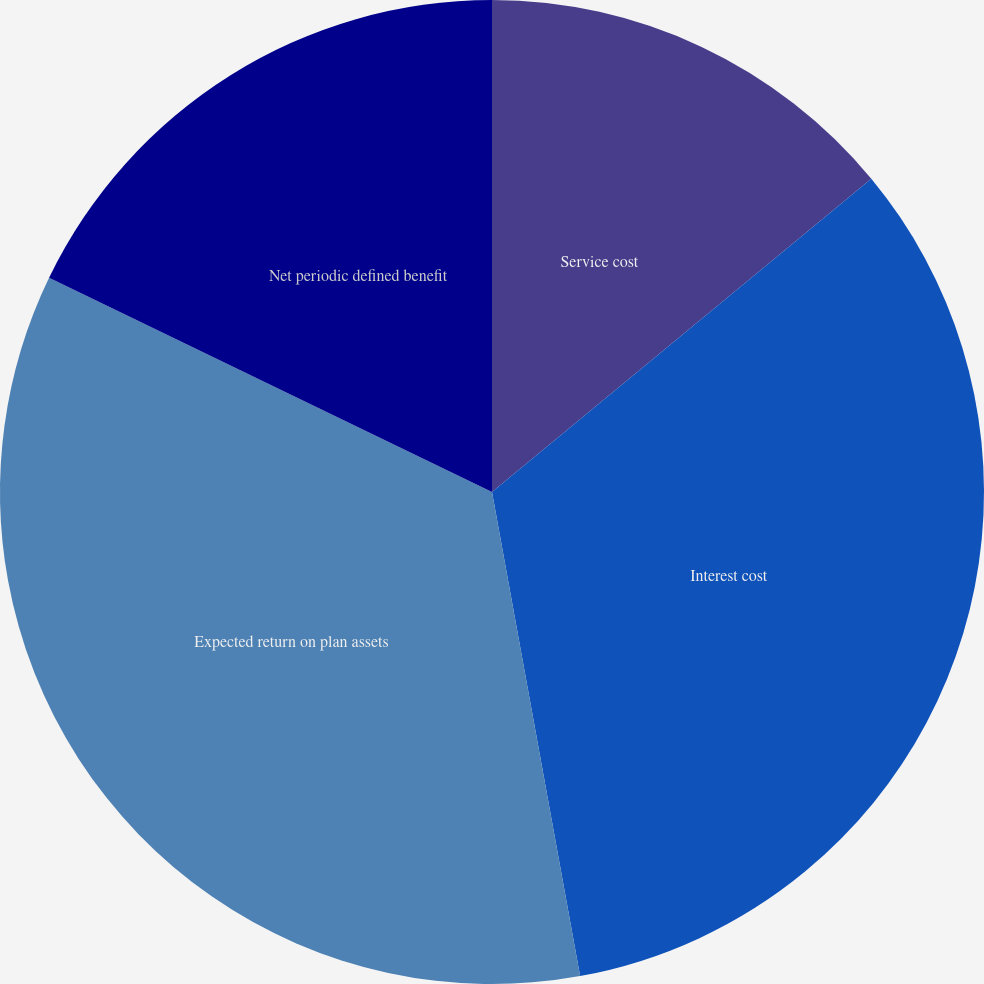Convert chart. <chart><loc_0><loc_0><loc_500><loc_500><pie_chart><fcel>Service cost<fcel>Interest cost<fcel>Expected return on plan assets<fcel>Net periodic defined benefit<nl><fcel>14.01%<fcel>33.12%<fcel>35.03%<fcel>17.83%<nl></chart> 